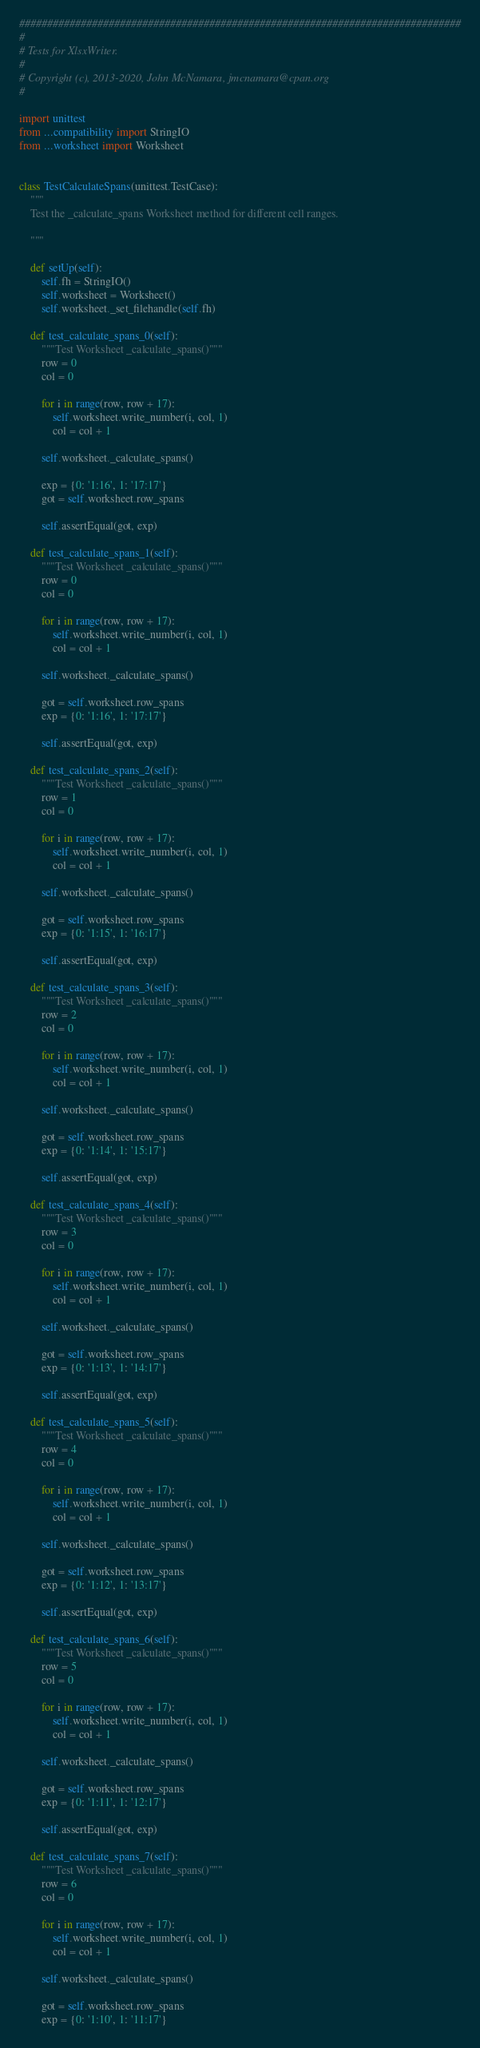Convert code to text. <code><loc_0><loc_0><loc_500><loc_500><_Python_>###############################################################################
#
# Tests for XlsxWriter.
#
# Copyright (c), 2013-2020, John McNamara, jmcnamara@cpan.org
#

import unittest
from ...compatibility import StringIO
from ...worksheet import Worksheet


class TestCalculateSpans(unittest.TestCase):
    """
    Test the _calculate_spans Worksheet method for different cell ranges.

    """

    def setUp(self):
        self.fh = StringIO()
        self.worksheet = Worksheet()
        self.worksheet._set_filehandle(self.fh)

    def test_calculate_spans_0(self):
        """Test Worksheet _calculate_spans()"""
        row = 0
        col = 0

        for i in range(row, row + 17):
            self.worksheet.write_number(i, col, 1)
            col = col + 1

        self.worksheet._calculate_spans()

        exp = {0: '1:16', 1: '17:17'}
        got = self.worksheet.row_spans

        self.assertEqual(got, exp)

    def test_calculate_spans_1(self):
        """Test Worksheet _calculate_spans()"""
        row = 0
        col = 0

        for i in range(row, row + 17):
            self.worksheet.write_number(i, col, 1)
            col = col + 1

        self.worksheet._calculate_spans()

        got = self.worksheet.row_spans
        exp = {0: '1:16', 1: '17:17'}

        self.assertEqual(got, exp)

    def test_calculate_spans_2(self):
        """Test Worksheet _calculate_spans()"""
        row = 1
        col = 0

        for i in range(row, row + 17):
            self.worksheet.write_number(i, col, 1)
            col = col + 1

        self.worksheet._calculate_spans()

        got = self.worksheet.row_spans
        exp = {0: '1:15', 1: '16:17'}

        self.assertEqual(got, exp)

    def test_calculate_spans_3(self):
        """Test Worksheet _calculate_spans()"""
        row = 2
        col = 0

        for i in range(row, row + 17):
            self.worksheet.write_number(i, col, 1)
            col = col + 1

        self.worksheet._calculate_spans()

        got = self.worksheet.row_spans
        exp = {0: '1:14', 1: '15:17'}

        self.assertEqual(got, exp)

    def test_calculate_spans_4(self):
        """Test Worksheet _calculate_spans()"""
        row = 3
        col = 0

        for i in range(row, row + 17):
            self.worksheet.write_number(i, col, 1)
            col = col + 1

        self.worksheet._calculate_spans()

        got = self.worksheet.row_spans
        exp = {0: '1:13', 1: '14:17'}

        self.assertEqual(got, exp)

    def test_calculate_spans_5(self):
        """Test Worksheet _calculate_spans()"""
        row = 4
        col = 0

        for i in range(row, row + 17):
            self.worksheet.write_number(i, col, 1)
            col = col + 1

        self.worksheet._calculate_spans()

        got = self.worksheet.row_spans
        exp = {0: '1:12', 1: '13:17'}

        self.assertEqual(got, exp)

    def test_calculate_spans_6(self):
        """Test Worksheet _calculate_spans()"""
        row = 5
        col = 0

        for i in range(row, row + 17):
            self.worksheet.write_number(i, col, 1)
            col = col + 1

        self.worksheet._calculate_spans()

        got = self.worksheet.row_spans
        exp = {0: '1:11', 1: '12:17'}

        self.assertEqual(got, exp)

    def test_calculate_spans_7(self):
        """Test Worksheet _calculate_spans()"""
        row = 6
        col = 0

        for i in range(row, row + 17):
            self.worksheet.write_number(i, col, 1)
            col = col + 1

        self.worksheet._calculate_spans()

        got = self.worksheet.row_spans
        exp = {0: '1:10', 1: '11:17'}
</code> 